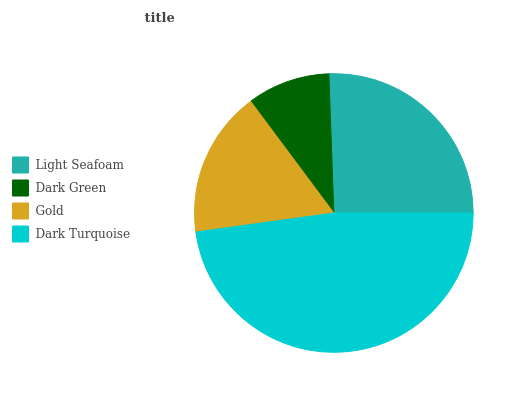Is Dark Green the minimum?
Answer yes or no. Yes. Is Dark Turquoise the maximum?
Answer yes or no. Yes. Is Gold the minimum?
Answer yes or no. No. Is Gold the maximum?
Answer yes or no. No. Is Gold greater than Dark Green?
Answer yes or no. Yes. Is Dark Green less than Gold?
Answer yes or no. Yes. Is Dark Green greater than Gold?
Answer yes or no. No. Is Gold less than Dark Green?
Answer yes or no. No. Is Light Seafoam the high median?
Answer yes or no. Yes. Is Gold the low median?
Answer yes or no. Yes. Is Gold the high median?
Answer yes or no. No. Is Dark Green the low median?
Answer yes or no. No. 